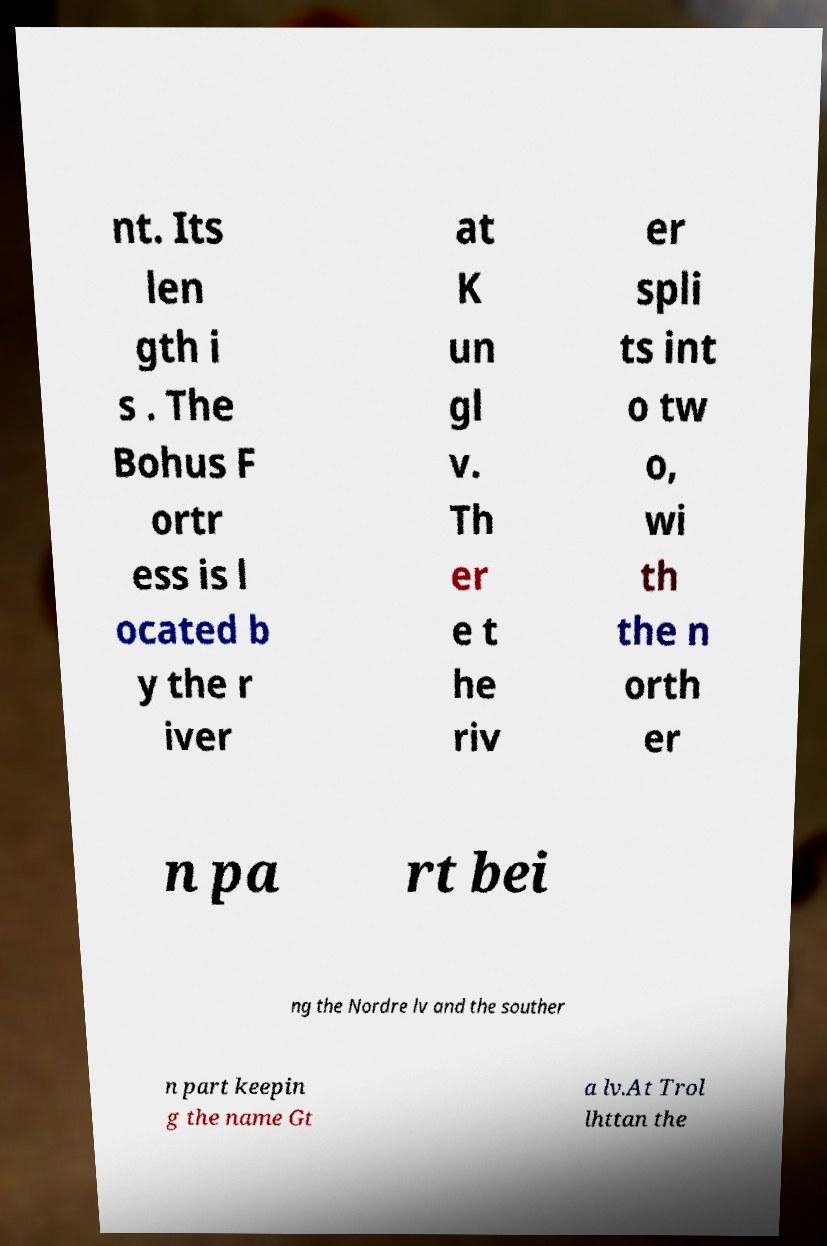Could you extract and type out the text from this image? nt. Its len gth i s . The Bohus F ortr ess is l ocated b y the r iver at K un gl v. Th er e t he riv er spli ts int o tw o, wi th the n orth er n pa rt bei ng the Nordre lv and the souther n part keepin g the name Gt a lv.At Trol lhttan the 